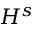<formula> <loc_0><loc_0><loc_500><loc_500>H ^ { s }</formula> 